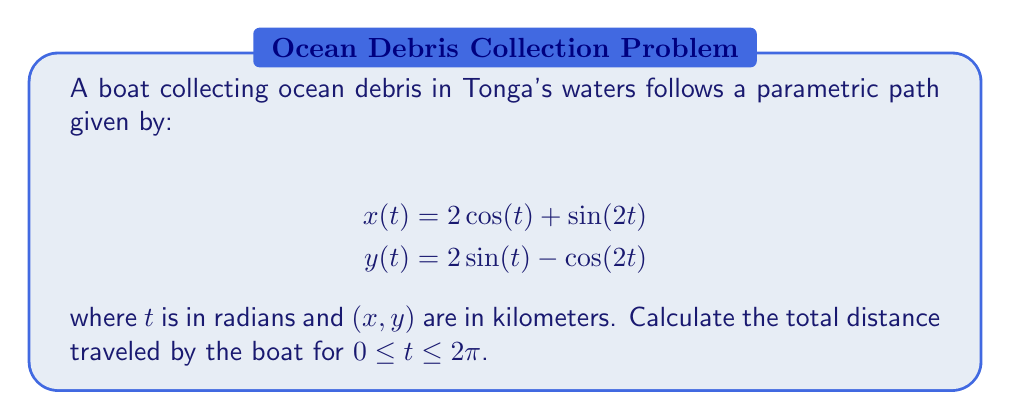Help me with this question. To find the total distance traveled, we need to calculate the arc length of the parametric curve. The formula for arc length is:

$$L = \int_a^b \sqrt{\left(\frac{dx}{dt}\right)^2 + \left(\frac{dy}{dt}\right)^2} dt$$

Let's follow these steps:

1) First, we need to find $\frac{dx}{dt}$ and $\frac{dy}{dt}$:

   $$\frac{dx}{dt} = -2\sin(t) + 2\cos(2t)$$
   $$\frac{dy}{dt} = 2\cos(t) + 2\sin(2t)$$

2) Now, we square these terms:

   $$\left(\frac{dx}{dt}\right)^2 = 4\sin^2(t) + 4\cos^2(2t) - 8\sin(t)\cos(2t)$$
   $$\left(\frac{dy}{dt}\right)^2 = 4\cos^2(t) + 4\sin^2(2t) + 8\cos(t)\sin(2t)$$

3) Add these together:

   $$\left(\frac{dx}{dt}\right)^2 + \left(\frac{dy}{dt}\right)^2 = 4\sin^2(t) + 4\cos^2(2t) - 8\sin(t)\cos(2t) + 4\cos^2(t) + 4\sin^2(2t) + 8\cos(t)\sin(2t)$$

4) Simplify using trigonometric identities:
   
   $\sin^2(t) + \cos^2(t) = 1$
   $\sin^2(2t) + \cos^2(2t) = 1$
   $\sin(2t) = 2\sin(t)\cos(t)$

   $$\left(\frac{dx}{dt}\right)^2 + \left(\frac{dy}{dt}\right)^2 = 4 + 4 = 8$$

5) Now our integral becomes:

   $$L = \int_0^{2\pi} \sqrt{8} dt = 2\sqrt{2} \int_0^{2\pi} dt = 2\sqrt{2} [t]_0^{2\pi} = 2\sqrt{2} (2\pi - 0) = 4\sqrt{2}\pi$$

Therefore, the total distance traveled is $4\sqrt{2}\pi$ kilometers.
Answer: $4\sqrt{2}\pi$ kilometers 